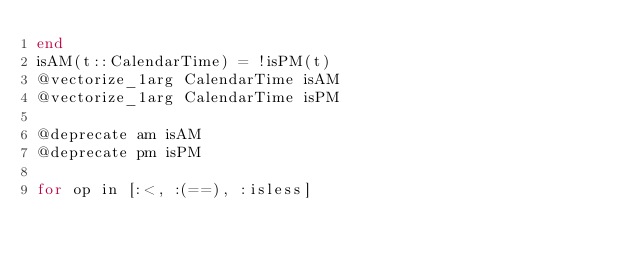<code> <loc_0><loc_0><loc_500><loc_500><_Julia_>end
isAM(t::CalendarTime) = !isPM(t)
@vectorize_1arg CalendarTime isAM
@vectorize_1arg CalendarTime isPM

@deprecate am isAM
@deprecate pm isPM

for op in [:<, :(==), :isless]</code> 